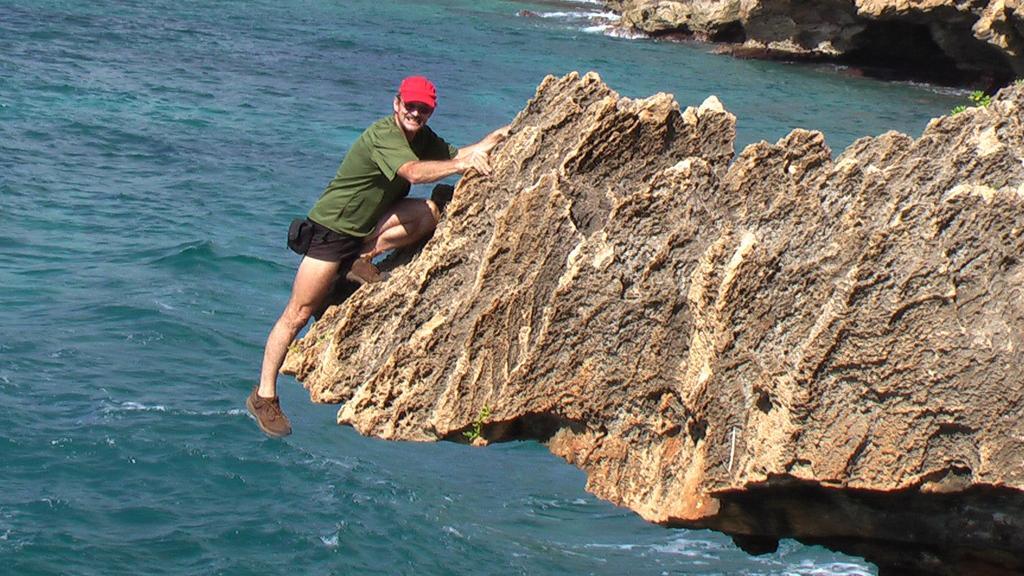In one or two sentences, can you explain what this image depicts? In this picture I can see a rock in front, on which there is a man and I see that he is wearing a cap, a t-shirt and shorts. In the background I can see the water and I see another rock. 